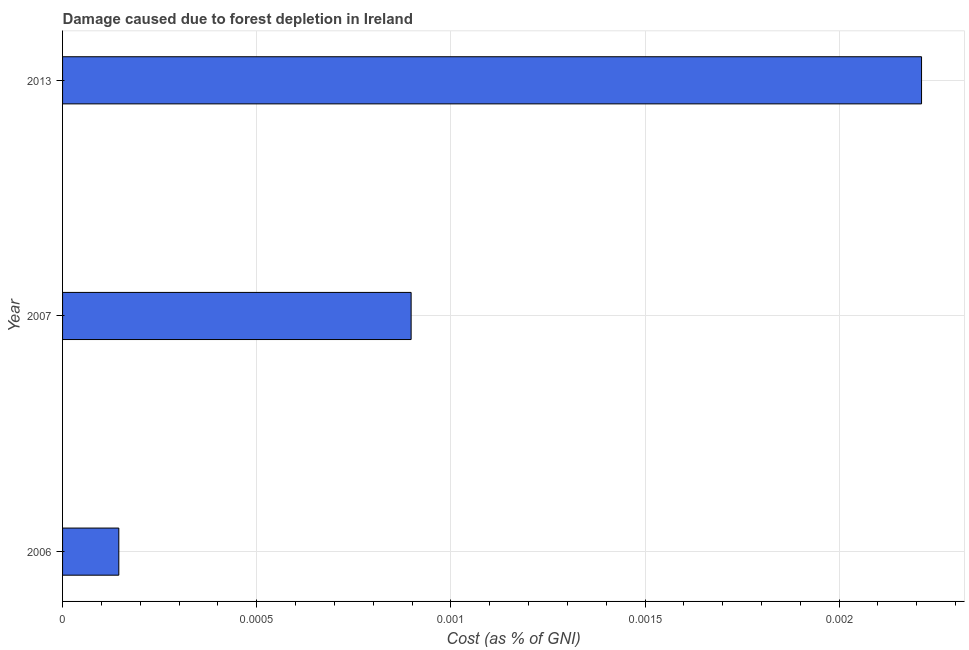Does the graph contain any zero values?
Your answer should be compact. No. What is the title of the graph?
Ensure brevity in your answer.  Damage caused due to forest depletion in Ireland. What is the label or title of the X-axis?
Provide a succinct answer. Cost (as % of GNI). What is the damage caused due to forest depletion in 2013?
Give a very brief answer. 0. Across all years, what is the maximum damage caused due to forest depletion?
Your response must be concise. 0. Across all years, what is the minimum damage caused due to forest depletion?
Your answer should be compact. 0. In which year was the damage caused due to forest depletion maximum?
Keep it short and to the point. 2013. What is the sum of the damage caused due to forest depletion?
Your answer should be very brief. 0. What is the difference between the damage caused due to forest depletion in 2007 and 2013?
Your answer should be very brief. -0. What is the median damage caused due to forest depletion?
Make the answer very short. 0. In how many years, is the damage caused due to forest depletion greater than 0.0007 %?
Keep it short and to the point. 2. What is the ratio of the damage caused due to forest depletion in 2006 to that in 2013?
Give a very brief answer. 0.07. What is the difference between the highest and the second highest damage caused due to forest depletion?
Give a very brief answer. 0. Is the sum of the damage caused due to forest depletion in 2006 and 2007 greater than the maximum damage caused due to forest depletion across all years?
Ensure brevity in your answer.  No. What is the difference between the highest and the lowest damage caused due to forest depletion?
Give a very brief answer. 0. How many bars are there?
Your response must be concise. 3. What is the Cost (as % of GNI) of 2006?
Provide a succinct answer. 0. What is the Cost (as % of GNI) in 2007?
Keep it short and to the point. 0. What is the Cost (as % of GNI) of 2013?
Your answer should be compact. 0. What is the difference between the Cost (as % of GNI) in 2006 and 2007?
Provide a succinct answer. -0. What is the difference between the Cost (as % of GNI) in 2006 and 2013?
Provide a short and direct response. -0. What is the difference between the Cost (as % of GNI) in 2007 and 2013?
Provide a succinct answer. -0. What is the ratio of the Cost (as % of GNI) in 2006 to that in 2007?
Your answer should be compact. 0.16. What is the ratio of the Cost (as % of GNI) in 2006 to that in 2013?
Make the answer very short. 0.07. What is the ratio of the Cost (as % of GNI) in 2007 to that in 2013?
Your response must be concise. 0.41. 